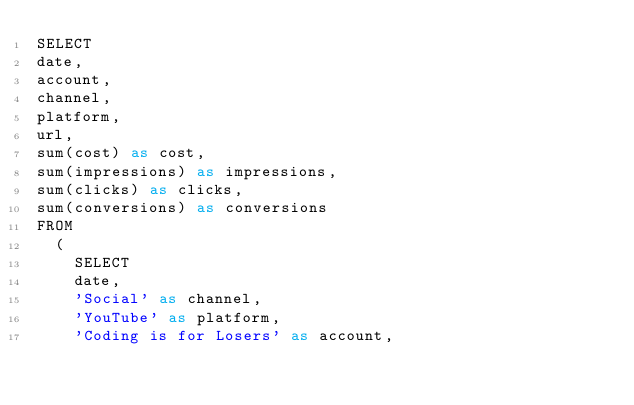<code> <loc_0><loc_0><loc_500><loc_500><_SQL_>SELECT
date, 
account, 
channel,
platform,
url,
sum(cost) as cost,
sum(impressions) as impressions,
sum(clicks) as clicks,
sum(conversions) as conversions
FROM 
  ( 
	SELECT  
	date, 
	'Social' as channel,
	'YouTube' as platform,
	'Coding is for Losers' as account,  </code> 